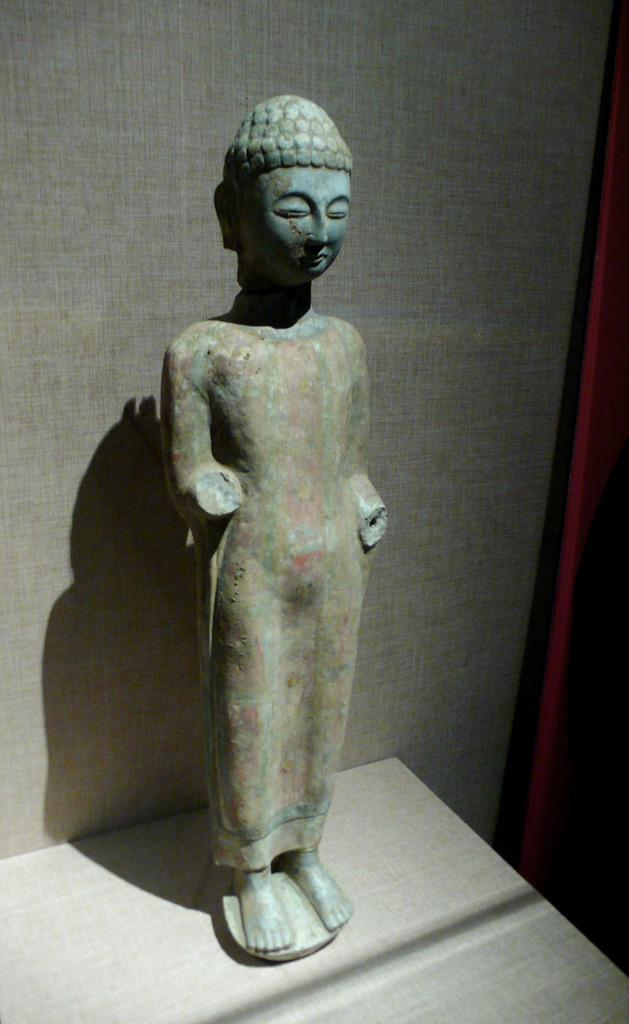What is the main subject of the image? There is a statue in the image. What is the statue resting on? The statue is on a cream-colored surface. What can be seen in the background of the image? There is a wall visible in the background of the image. How many people are paying attention to the statue in the image? There is no indication of people or a crowd in the image, so it is impossible to determine how many people might be paying attention to the statue. 